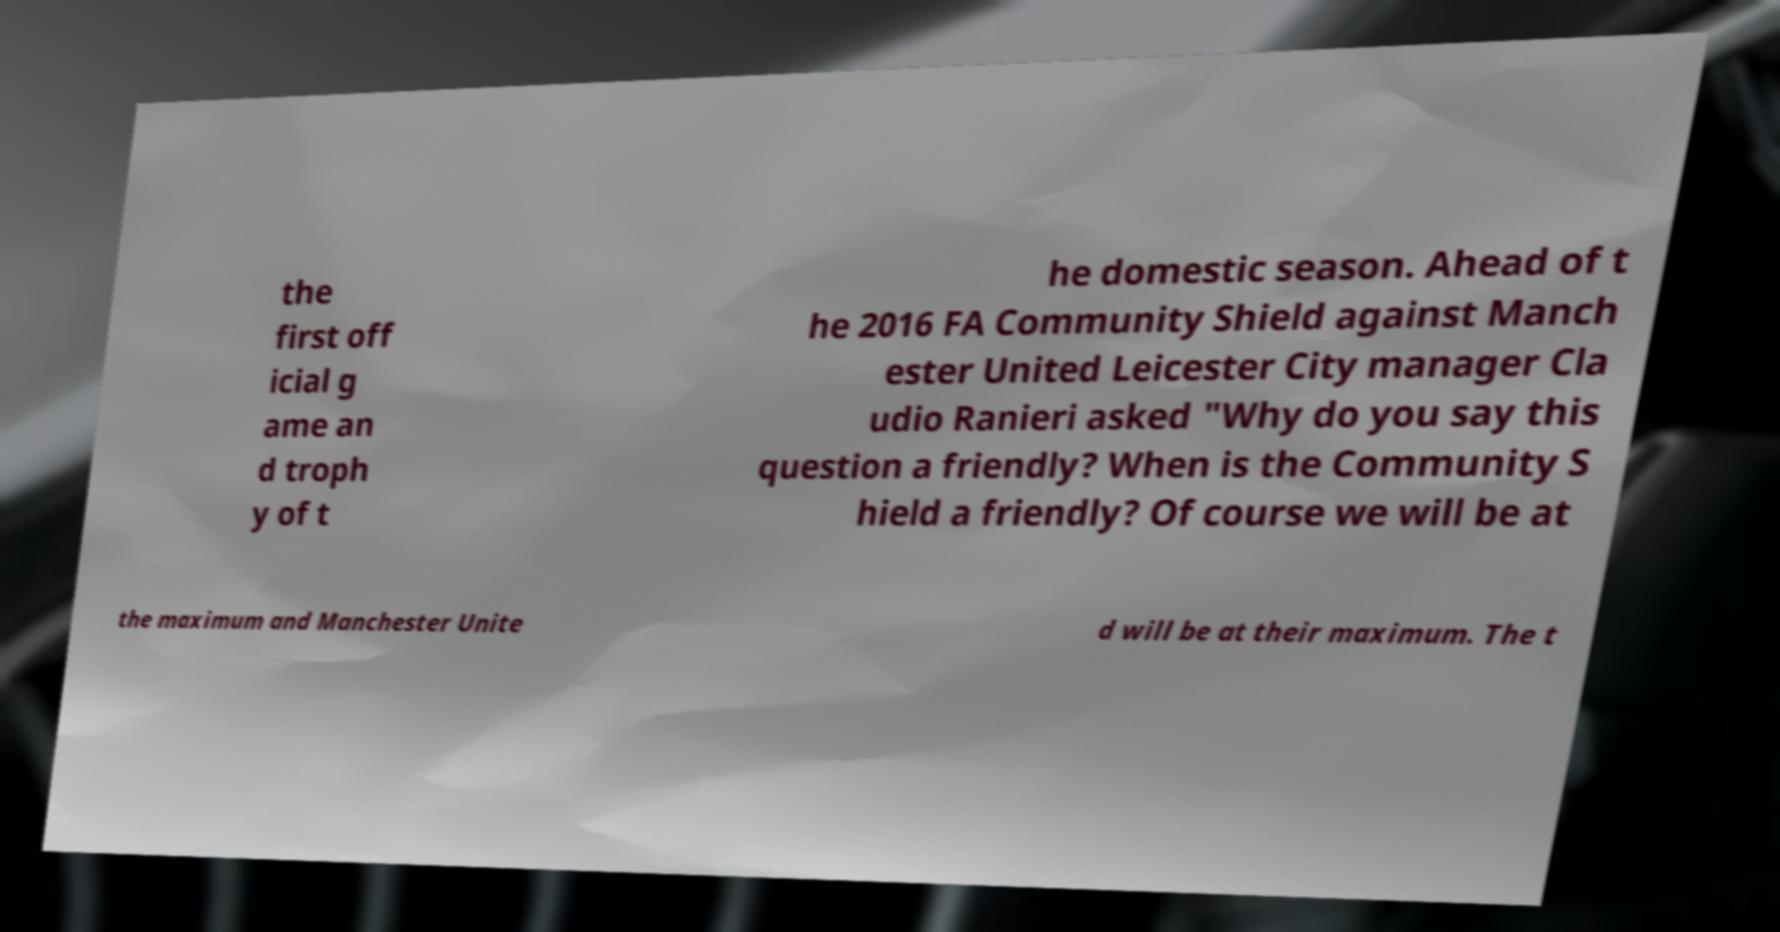What messages or text are displayed in this image? I need them in a readable, typed format. the first off icial g ame an d troph y of t he domestic season. Ahead of t he 2016 FA Community Shield against Manch ester United Leicester City manager Cla udio Ranieri asked "Why do you say this question a friendly? When is the Community S hield a friendly? Of course we will be at the maximum and Manchester Unite d will be at their maximum. The t 